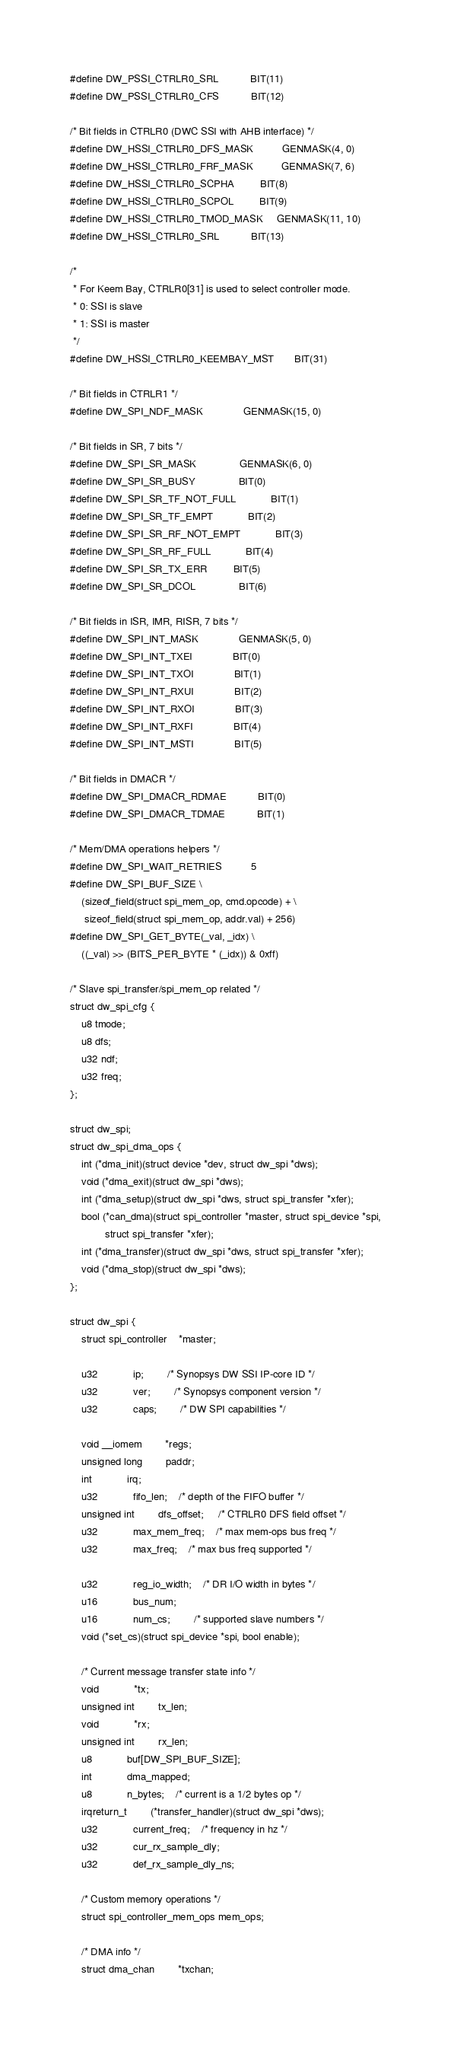Convert code to text. <code><loc_0><loc_0><loc_500><loc_500><_C_>#define DW_PSSI_CTRLR0_SRL			BIT(11)
#define DW_PSSI_CTRLR0_CFS			BIT(12)

/* Bit fields in CTRLR0 (DWC SSI with AHB interface) */
#define DW_HSSI_CTRLR0_DFS_MASK			GENMASK(4, 0)
#define DW_HSSI_CTRLR0_FRF_MASK			GENMASK(7, 6)
#define DW_HSSI_CTRLR0_SCPHA			BIT(8)
#define DW_HSSI_CTRLR0_SCPOL			BIT(9)
#define DW_HSSI_CTRLR0_TMOD_MASK		GENMASK(11, 10)
#define DW_HSSI_CTRLR0_SRL			BIT(13)

/*
 * For Keem Bay, CTRLR0[31] is used to select controller mode.
 * 0: SSI is slave
 * 1: SSI is master
 */
#define DW_HSSI_CTRLR0_KEEMBAY_MST		BIT(31)

/* Bit fields in CTRLR1 */
#define DW_SPI_NDF_MASK				GENMASK(15, 0)

/* Bit fields in SR, 7 bits */
#define DW_SPI_SR_MASK				GENMASK(6, 0)
#define DW_SPI_SR_BUSY				BIT(0)
#define DW_SPI_SR_TF_NOT_FULL			BIT(1)
#define DW_SPI_SR_TF_EMPT			BIT(2)
#define DW_SPI_SR_RF_NOT_EMPT			BIT(3)
#define DW_SPI_SR_RF_FULL			BIT(4)
#define DW_SPI_SR_TX_ERR			BIT(5)
#define DW_SPI_SR_DCOL				BIT(6)

/* Bit fields in ISR, IMR, RISR, 7 bits */
#define DW_SPI_INT_MASK				GENMASK(5, 0)
#define DW_SPI_INT_TXEI				BIT(0)
#define DW_SPI_INT_TXOI				BIT(1)
#define DW_SPI_INT_RXUI				BIT(2)
#define DW_SPI_INT_RXOI				BIT(3)
#define DW_SPI_INT_RXFI				BIT(4)
#define DW_SPI_INT_MSTI				BIT(5)

/* Bit fields in DMACR */
#define DW_SPI_DMACR_RDMAE			BIT(0)
#define DW_SPI_DMACR_TDMAE			BIT(1)

/* Mem/DMA operations helpers */
#define DW_SPI_WAIT_RETRIES			5
#define DW_SPI_BUF_SIZE \
	(sizeof_field(struct spi_mem_op, cmd.opcode) + \
	 sizeof_field(struct spi_mem_op, addr.val) + 256)
#define DW_SPI_GET_BYTE(_val, _idx) \
	((_val) >> (BITS_PER_BYTE * (_idx)) & 0xff)

/* Slave spi_transfer/spi_mem_op related */
struct dw_spi_cfg {
	u8 tmode;
	u8 dfs;
	u32 ndf;
	u32 freq;
};

struct dw_spi;
struct dw_spi_dma_ops {
	int (*dma_init)(struct device *dev, struct dw_spi *dws);
	void (*dma_exit)(struct dw_spi *dws);
	int (*dma_setup)(struct dw_spi *dws, struct spi_transfer *xfer);
	bool (*can_dma)(struct spi_controller *master, struct spi_device *spi,
			struct spi_transfer *xfer);
	int (*dma_transfer)(struct dw_spi *dws, struct spi_transfer *xfer);
	void (*dma_stop)(struct dw_spi *dws);
};

struct dw_spi {
	struct spi_controller	*master;

	u32			ip;		/* Synopsys DW SSI IP-core ID */
	u32			ver;		/* Synopsys component version */
	u32			caps;		/* DW SPI capabilities */

	void __iomem		*regs;
	unsigned long		paddr;
	int			irq;
	u32			fifo_len;	/* depth of the FIFO buffer */
	unsigned int		dfs_offset;     /* CTRLR0 DFS field offset */
	u32			max_mem_freq;	/* max mem-ops bus freq */
	u32			max_freq;	/* max bus freq supported */

	u32			reg_io_width;	/* DR I/O width in bytes */
	u16			bus_num;
	u16			num_cs;		/* supported slave numbers */
	void (*set_cs)(struct spi_device *spi, bool enable);

	/* Current message transfer state info */
	void			*tx;
	unsigned int		tx_len;
	void			*rx;
	unsigned int		rx_len;
	u8			buf[DW_SPI_BUF_SIZE];
	int			dma_mapped;
	u8			n_bytes;	/* current is a 1/2 bytes op */
	irqreturn_t		(*transfer_handler)(struct dw_spi *dws);
	u32			current_freq;	/* frequency in hz */
	u32			cur_rx_sample_dly;
	u32			def_rx_sample_dly_ns;

	/* Custom memory operations */
	struct spi_controller_mem_ops mem_ops;

	/* DMA info */
	struct dma_chan		*txchan;</code> 